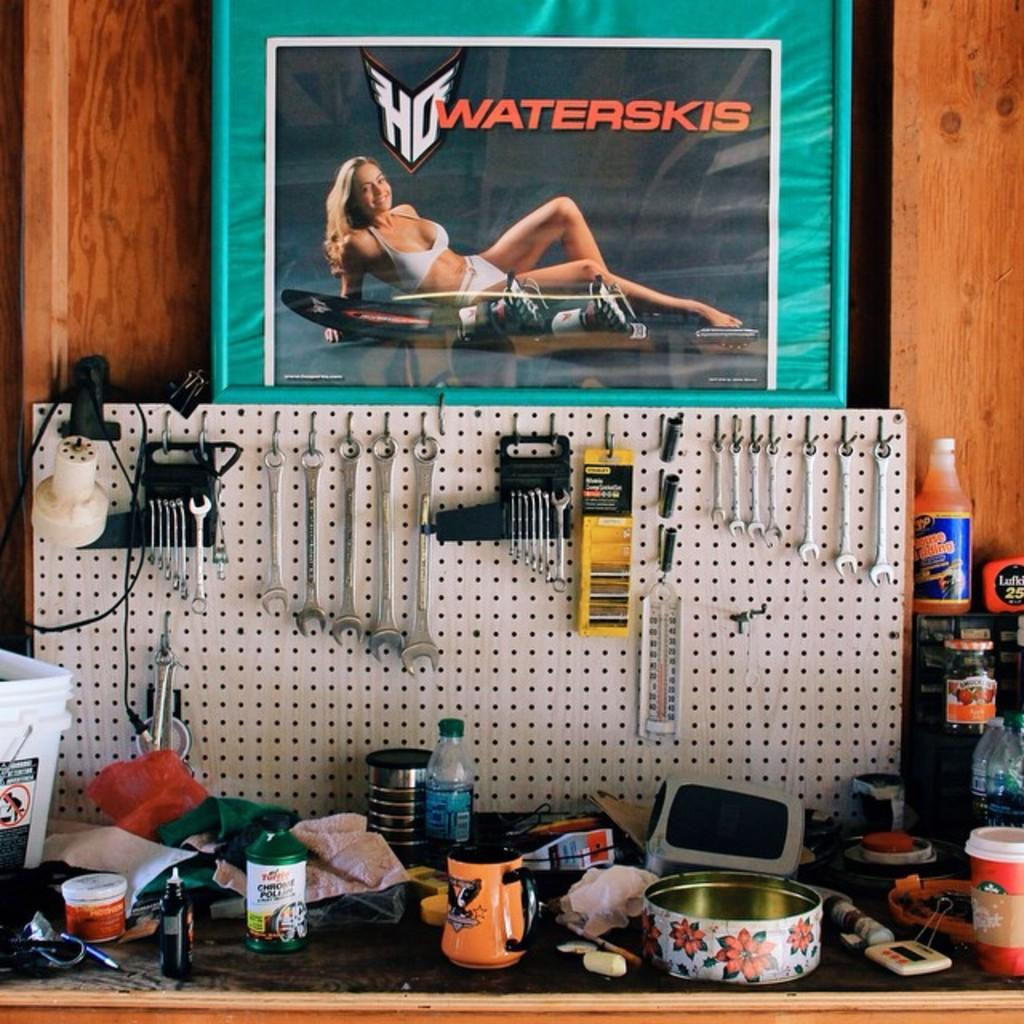What is hanging on the wall in the image? There is a frame, a poster, mechanic repair tools, a bottle, a cup, and a bowl hanging on the wall in the image. Can you describe the poster on the wall? The poster on the wall is not specified in the facts provided. What type of objects are the mechanic repair tools? The mechanic repair tools are not specified in the facts provided. What is the purpose of the bottle, cup, and bowl on the wall? The purpose of the bottle, cup, and bowl on the wall is not specified in the facts provided. What type of heart can be seen beating in the image? There is no heart present in the image. What is the purpose of the brick on the wall in the image? There is no brick present in the image. 